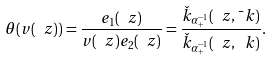Convert formula to latex. <formula><loc_0><loc_0><loc_500><loc_500>\theta ( v ( \ z ) ) = \frac { e _ { 1 } ( \ z ) } { v ( \ z ) e _ { 2 } ( \ z ) } = \frac { \check { k } _ { \alpha _ { + } ^ { - 1 } } ( \ z , \bar { \ } k ) } { \check { k } _ { \alpha _ { + } ^ { - 1 } } ( \ z , \ k ) } .</formula> 